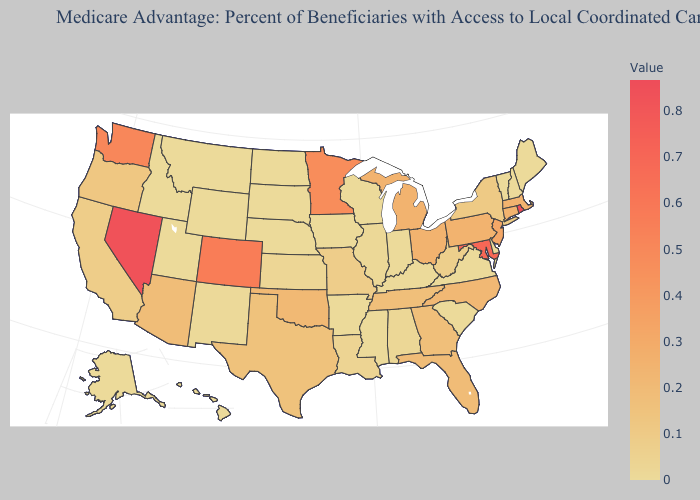Does Nebraska have the lowest value in the MidWest?
Give a very brief answer. Yes. Which states have the lowest value in the South?
Answer briefly. Arkansas, Delaware, Kentucky, Mississippi, South Carolina, Virginia. Which states have the highest value in the USA?
Write a very short answer. Rhode Island. Which states have the highest value in the USA?
Be succinct. Rhode Island. Does the map have missing data?
Answer briefly. No. Among the states that border Arkansas , does Oklahoma have the highest value?
Short answer required. Yes. Which states have the lowest value in the Northeast?
Answer briefly. Maine, New Hampshire, Vermont. 